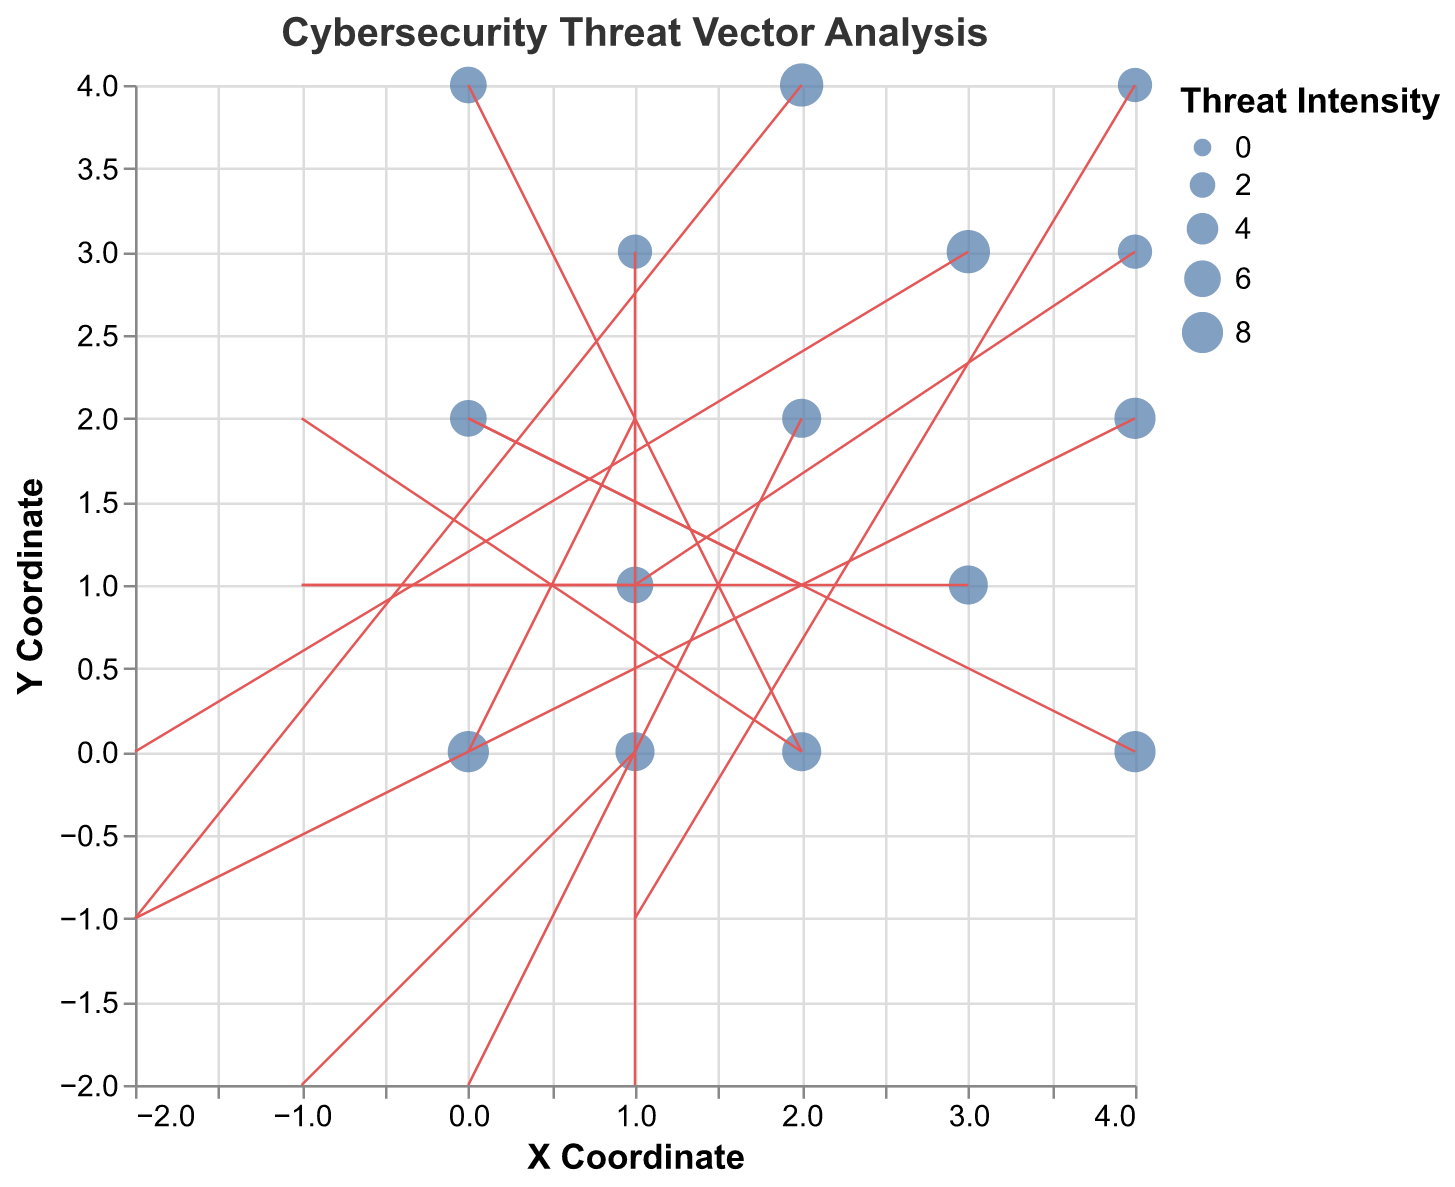What is the title of the plot? The title of the plot is a direct text element displayed prominently at the top of the plot, indicating the subject of the figure.
Answer: Cybersecurity Threat Vector Analysis What do the points in the figure represent? The points represent the initial positions of various cybersecurity threats on government infrastructure, with their size indicating the intensity of the threat.
Answer: Initial threat positions and intensities Which data point has the highest threat intensity? Identify the largest point in the plot by comparing the sizes, as larger size indicates higher intensity.
Answer: Point at (3,3) with intensity 9 What are the x and y coordinates of the vector with the highest intensity? Find the point with the largest size and read its coordinates. The highest intensity is 9, located at coordinates (3,3).
Answer: (3, 3) How many vectors are pointing in the negative x direction? One must count the arrows with negative 'u' values. There are five arrows with negative 'u' values.
Answer: 5 What is the sum of the threat intensities for vectors originating from the y = 2 line? Sum up the values from all points where y = 2. The intensities for y = 2 are 7 (at x=2), 6 (at x=0), and 8 (at x=4). Therefore, 7 + 6 + 8 = 21.
Answer: 21 Which vector has the largest magnitude in the negative y direction? Review all vectors with negative 'v' values and determine their magnitudes. Calculate magnitude via the Euclidean Norm \(\sqrt{u^2 + v^2}\). Vector (1,-2) at (1,0) has a magnitude of \(\sqrt{1^2 + (-2)^2} = \sqrt{5}\).
Answer: Vector at (1,0) What is observed from the overall directionality of the threat vectors? Most vectors are pointing in mixed directions, with no singular dominant direction, indicating that threats come from multiple directions towards various points of government infrastructure.
Answer: Mixed directions How does the plot visualize the intensity of the threats? The intensity is visualized through the size of the points, with larger points indicating higher intensity.
Answer: Size of points with larger meaning higher intensity 